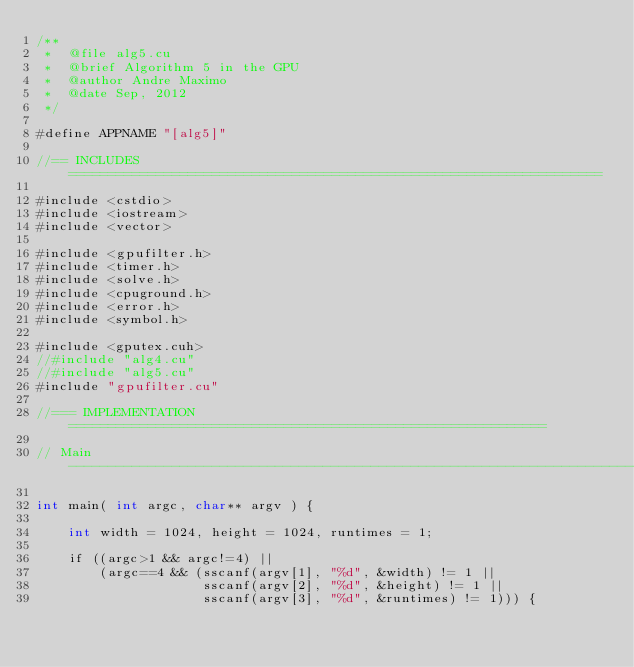<code> <loc_0><loc_0><loc_500><loc_500><_Cuda_>/**
 *  @file alg5.cu
 *  @brief Algorithm 5 in the GPU
 *  @author Andre Maximo
 *  @date Sep, 2012
 */

#define APPNAME "[alg5]"

//== INCLUDES ===================================================================

#include <cstdio>
#include <iostream>
#include <vector>

#include <gpufilter.h>
#include <timer.h>
#include <solve.h>
#include <cpuground.h>
#include <error.h>
#include <symbol.h>

#include <gputex.cuh>
//#include "alg4.cu"
//#include "alg5.cu"
#include "gpufilter.cu"

//=== IMPLEMENTATION ============================================================

// Main -------------------------------------------------------------------------

int main( int argc, char** argv ) {

    int width = 1024, height = 1024, runtimes = 1;

    if ((argc>1 && argc!=4) ||
        (argc==4 && (sscanf(argv[1], "%d", &width) != 1 ||
                     sscanf(argv[2], "%d", &height) != 1 ||
                     sscanf(argv[3], "%d", &runtimes) != 1))) {</code> 